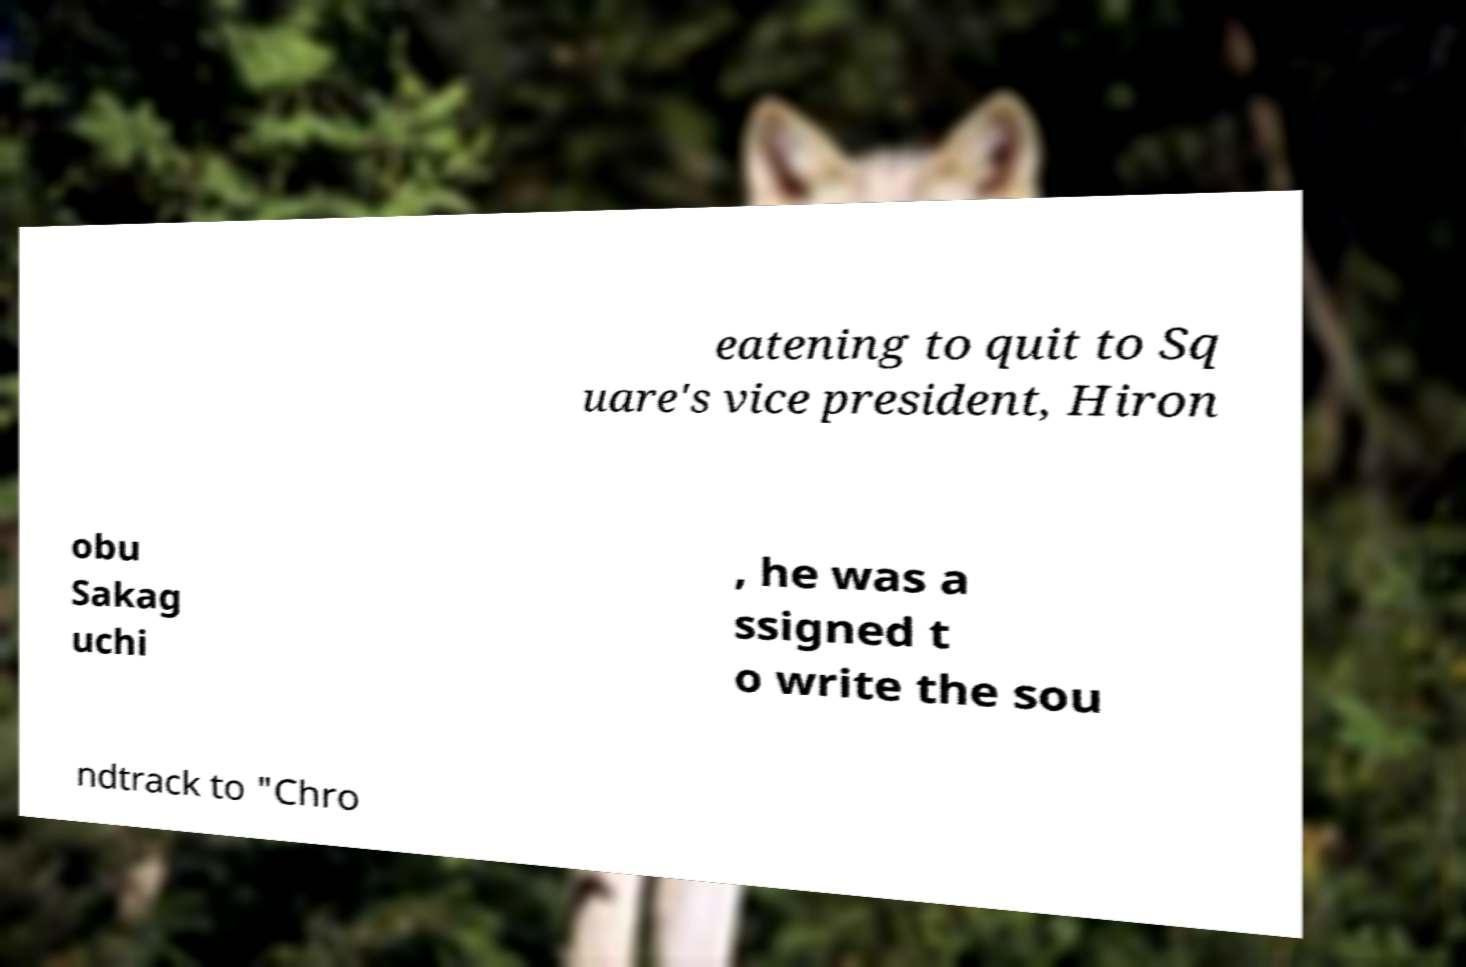Can you read and provide the text displayed in the image?This photo seems to have some interesting text. Can you extract and type it out for me? eatening to quit to Sq uare's vice president, Hiron obu Sakag uchi , he was a ssigned t o write the sou ndtrack to "Chro 